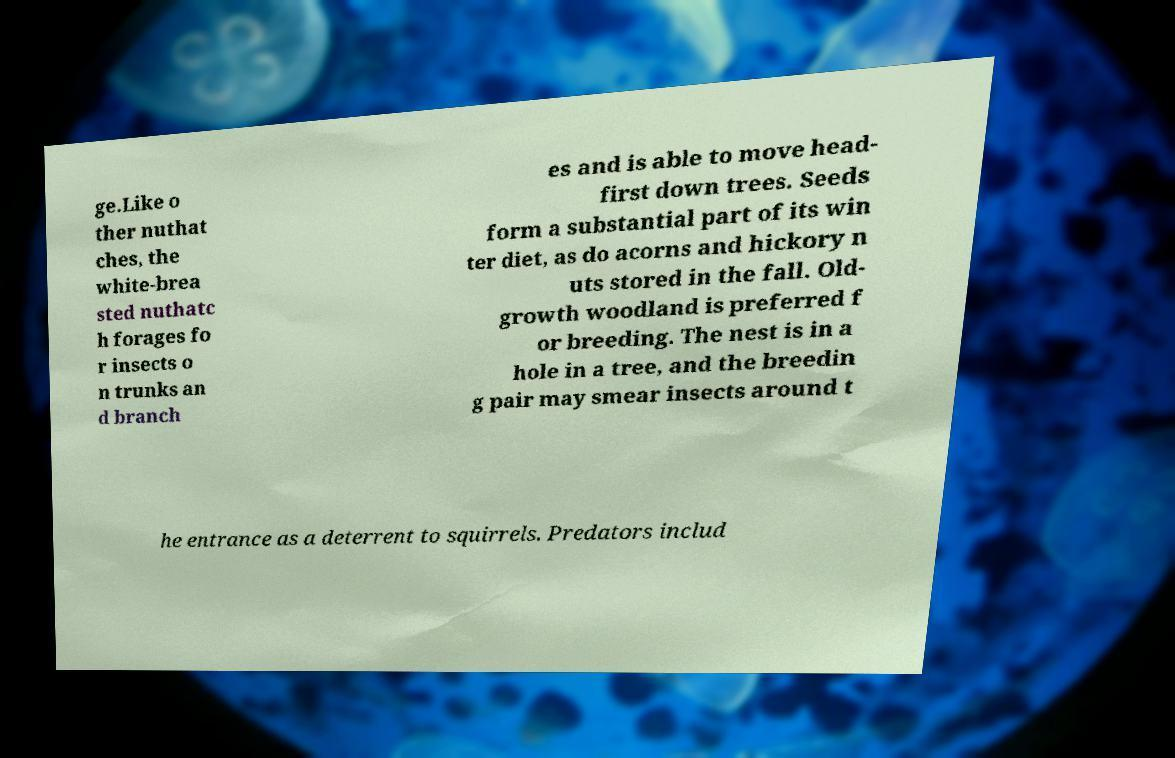What messages or text are displayed in this image? I need them in a readable, typed format. ge.Like o ther nuthat ches, the white-brea sted nuthatc h forages fo r insects o n trunks an d branch es and is able to move head- first down trees. Seeds form a substantial part of its win ter diet, as do acorns and hickory n uts stored in the fall. Old- growth woodland is preferred f or breeding. The nest is in a hole in a tree, and the breedin g pair may smear insects around t he entrance as a deterrent to squirrels. Predators includ 